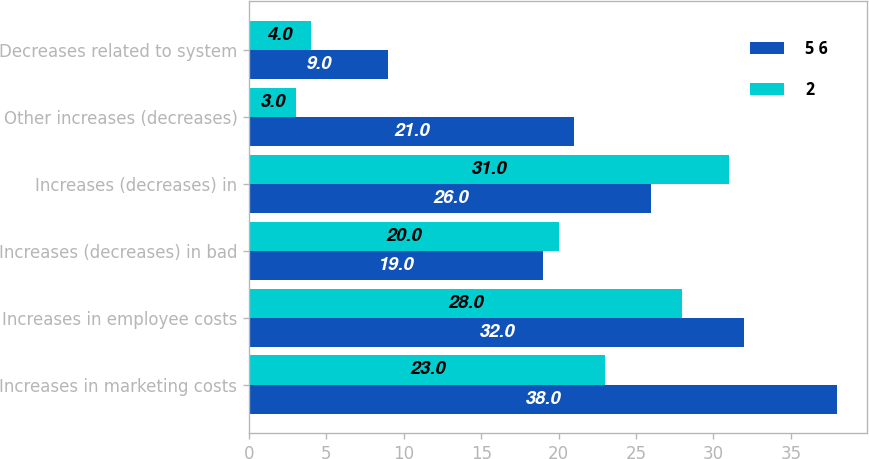<chart> <loc_0><loc_0><loc_500><loc_500><stacked_bar_chart><ecel><fcel>Increases in marketing costs<fcel>Increases in employee costs<fcel>Increases (decreases) in bad<fcel>Increases (decreases) in<fcel>Other increases (decreases)<fcel>Decreases related to system<nl><fcel>5 6<fcel>38<fcel>32<fcel>19<fcel>26<fcel>21<fcel>9<nl><fcel>2<fcel>23<fcel>28<fcel>20<fcel>31<fcel>3<fcel>4<nl></chart> 